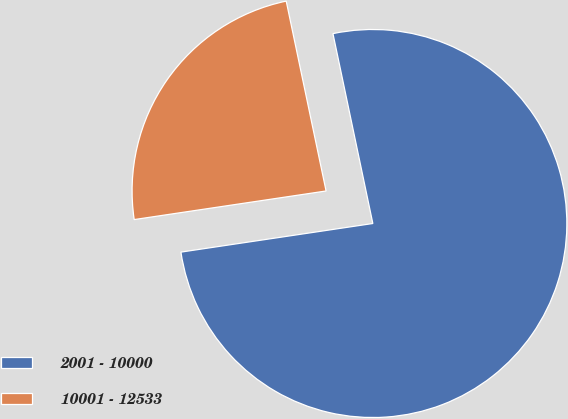Convert chart to OTSL. <chart><loc_0><loc_0><loc_500><loc_500><pie_chart><fcel>2001 - 10000<fcel>10001 - 12533<nl><fcel>75.94%<fcel>24.06%<nl></chart> 